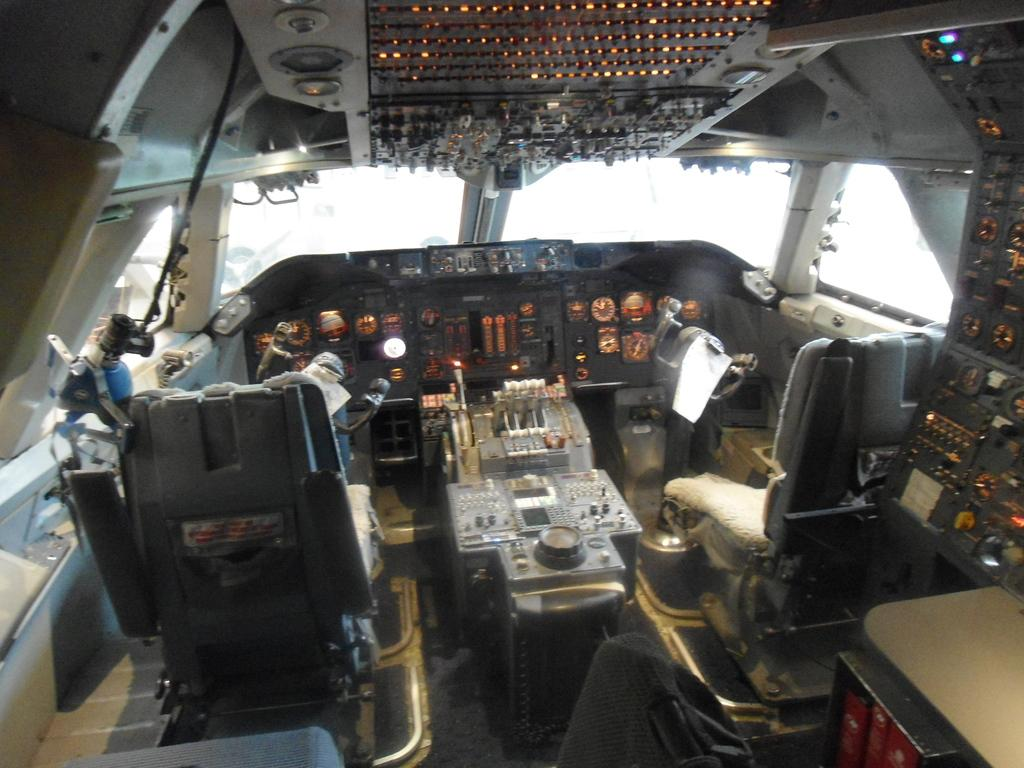What type of location is depicted in the image? The image shows the interior of an aircraft. What can be seen in the background of the image? The background of the image features a sky in white color. Where is the sweater located in the image? There is no sweater present in the image. Can you see a goldfish swimming in the sky in the image? There is no goldfish present in the image; the sky in the background is white. 